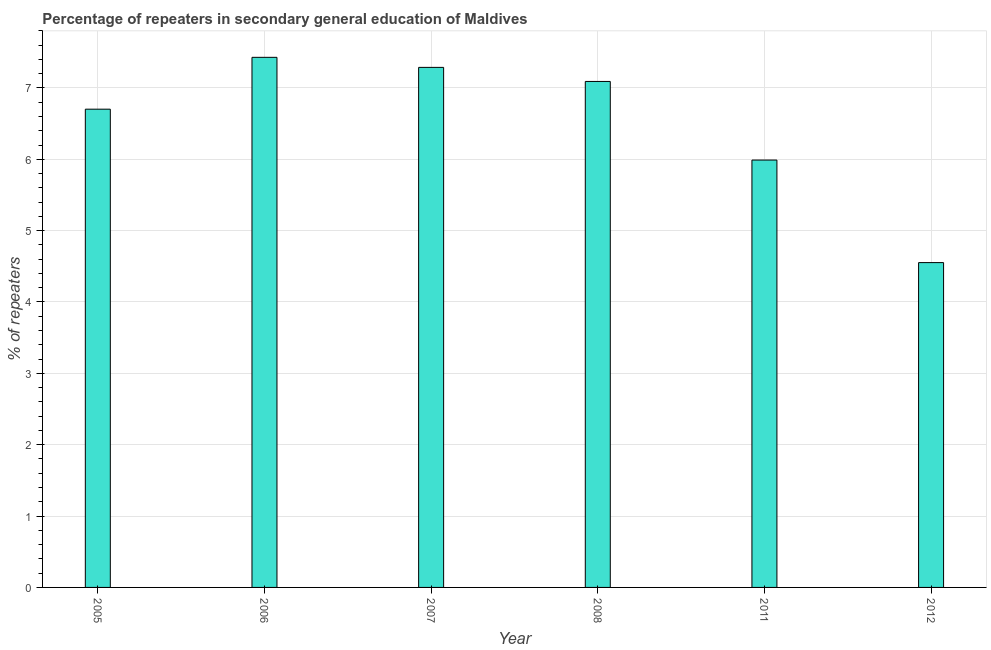What is the title of the graph?
Keep it short and to the point. Percentage of repeaters in secondary general education of Maldives. What is the label or title of the Y-axis?
Offer a very short reply. % of repeaters. What is the percentage of repeaters in 2012?
Ensure brevity in your answer.  4.55. Across all years, what is the maximum percentage of repeaters?
Offer a terse response. 7.43. Across all years, what is the minimum percentage of repeaters?
Offer a terse response. 4.55. In which year was the percentage of repeaters minimum?
Ensure brevity in your answer.  2012. What is the sum of the percentage of repeaters?
Give a very brief answer. 39.05. What is the difference between the percentage of repeaters in 2007 and 2008?
Your response must be concise. 0.2. What is the average percentage of repeaters per year?
Ensure brevity in your answer.  6.51. What is the median percentage of repeaters?
Your answer should be very brief. 6.9. Do a majority of the years between 2006 and 2011 (inclusive) have percentage of repeaters greater than 3 %?
Keep it short and to the point. Yes. What is the ratio of the percentage of repeaters in 2007 to that in 2011?
Ensure brevity in your answer.  1.22. Is the difference between the percentage of repeaters in 2005 and 2012 greater than the difference between any two years?
Give a very brief answer. No. What is the difference between the highest and the second highest percentage of repeaters?
Offer a terse response. 0.14. Is the sum of the percentage of repeaters in 2006 and 2008 greater than the maximum percentage of repeaters across all years?
Offer a terse response. Yes. What is the difference between the highest and the lowest percentage of repeaters?
Your response must be concise. 2.88. How many bars are there?
Make the answer very short. 6. Are all the bars in the graph horizontal?
Offer a terse response. No. How many years are there in the graph?
Provide a short and direct response. 6. Are the values on the major ticks of Y-axis written in scientific E-notation?
Give a very brief answer. No. What is the % of repeaters of 2005?
Offer a terse response. 6.7. What is the % of repeaters of 2006?
Your answer should be very brief. 7.43. What is the % of repeaters of 2007?
Ensure brevity in your answer.  7.29. What is the % of repeaters of 2008?
Ensure brevity in your answer.  7.09. What is the % of repeaters of 2011?
Your answer should be very brief. 5.99. What is the % of repeaters in 2012?
Your answer should be very brief. 4.55. What is the difference between the % of repeaters in 2005 and 2006?
Offer a very short reply. -0.73. What is the difference between the % of repeaters in 2005 and 2007?
Your answer should be very brief. -0.59. What is the difference between the % of repeaters in 2005 and 2008?
Your answer should be compact. -0.39. What is the difference between the % of repeaters in 2005 and 2011?
Make the answer very short. 0.71. What is the difference between the % of repeaters in 2005 and 2012?
Your response must be concise. 2.15. What is the difference between the % of repeaters in 2006 and 2007?
Keep it short and to the point. 0.14. What is the difference between the % of repeaters in 2006 and 2008?
Give a very brief answer. 0.34. What is the difference between the % of repeaters in 2006 and 2011?
Offer a terse response. 1.44. What is the difference between the % of repeaters in 2006 and 2012?
Your answer should be very brief. 2.88. What is the difference between the % of repeaters in 2007 and 2008?
Provide a short and direct response. 0.2. What is the difference between the % of repeaters in 2007 and 2011?
Your response must be concise. 1.3. What is the difference between the % of repeaters in 2007 and 2012?
Keep it short and to the point. 2.74. What is the difference between the % of repeaters in 2008 and 2011?
Make the answer very short. 1.1. What is the difference between the % of repeaters in 2008 and 2012?
Provide a succinct answer. 2.54. What is the difference between the % of repeaters in 2011 and 2012?
Keep it short and to the point. 1.44. What is the ratio of the % of repeaters in 2005 to that in 2006?
Offer a very short reply. 0.9. What is the ratio of the % of repeaters in 2005 to that in 2008?
Your response must be concise. 0.94. What is the ratio of the % of repeaters in 2005 to that in 2011?
Ensure brevity in your answer.  1.12. What is the ratio of the % of repeaters in 2005 to that in 2012?
Offer a very short reply. 1.47. What is the ratio of the % of repeaters in 2006 to that in 2007?
Your response must be concise. 1.02. What is the ratio of the % of repeaters in 2006 to that in 2008?
Offer a terse response. 1.05. What is the ratio of the % of repeaters in 2006 to that in 2011?
Keep it short and to the point. 1.24. What is the ratio of the % of repeaters in 2006 to that in 2012?
Your response must be concise. 1.63. What is the ratio of the % of repeaters in 2007 to that in 2008?
Your response must be concise. 1.03. What is the ratio of the % of repeaters in 2007 to that in 2011?
Your response must be concise. 1.22. What is the ratio of the % of repeaters in 2007 to that in 2012?
Offer a very short reply. 1.6. What is the ratio of the % of repeaters in 2008 to that in 2011?
Offer a very short reply. 1.18. What is the ratio of the % of repeaters in 2008 to that in 2012?
Your answer should be very brief. 1.56. What is the ratio of the % of repeaters in 2011 to that in 2012?
Your answer should be compact. 1.32. 